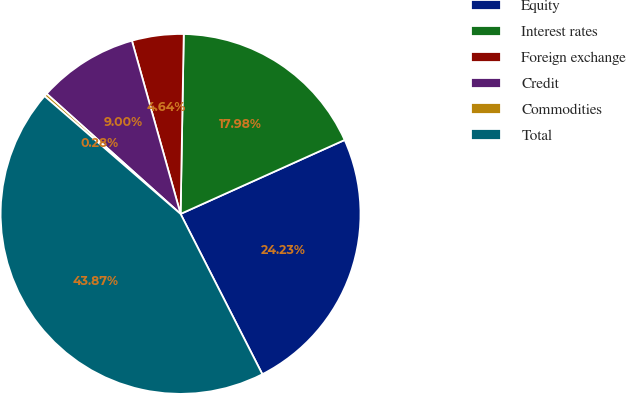<chart> <loc_0><loc_0><loc_500><loc_500><pie_chart><fcel>Equity<fcel>Interest rates<fcel>Foreign exchange<fcel>Credit<fcel>Commodities<fcel>Total<nl><fcel>24.23%<fcel>17.98%<fcel>4.64%<fcel>9.0%<fcel>0.28%<fcel>43.87%<nl></chart> 